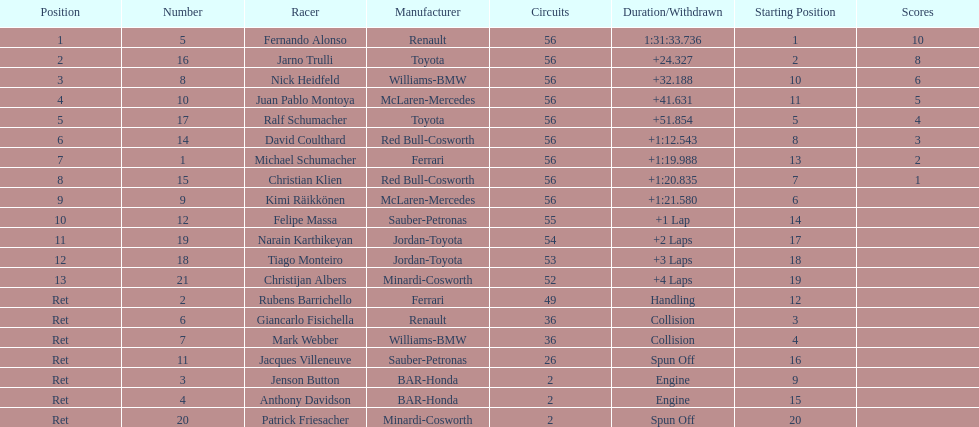How long did it take fernando alonso to finish the race? 1:31:33.736. 